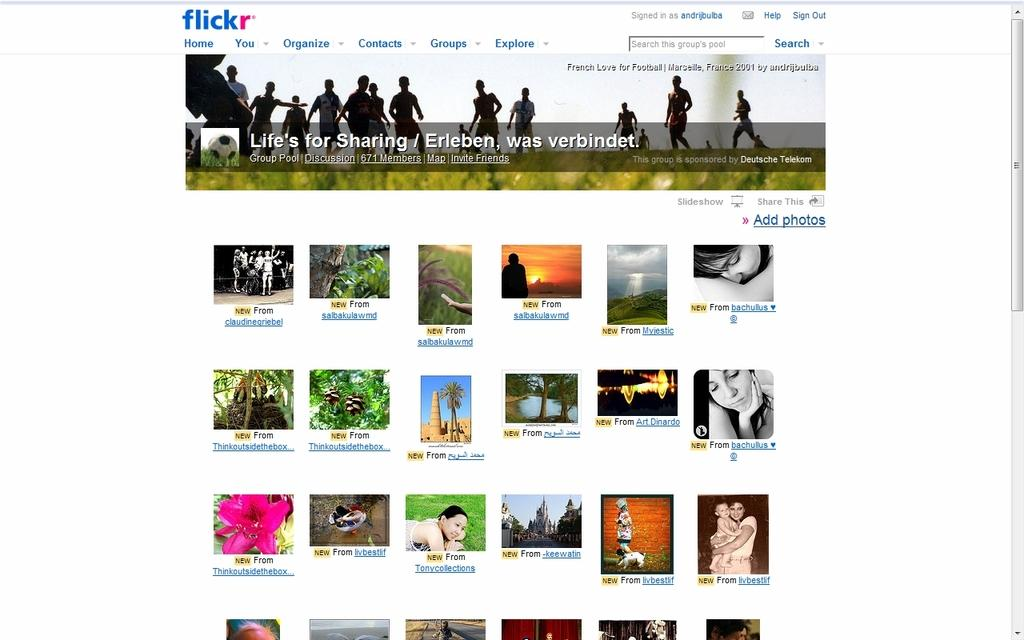How many people are in the group visible in the image? There is a group of people in the image, but the exact number cannot be determined from the provided facts. What can be seen in addition to the people in the image? There is text, flowers, the sun, trees, and other objects present in the image. What is the source of light in the image? The sun is visible in the image, which suggests it is the source of light. What type of vegetation is present in the image? There are trees in the image, which indicates the presence of vegetation. What type of polish is being applied to the legs of the table in the image? There is no table or polish present in the image; it features a group of people, text, flowers, the sun, trees, and other objects. 